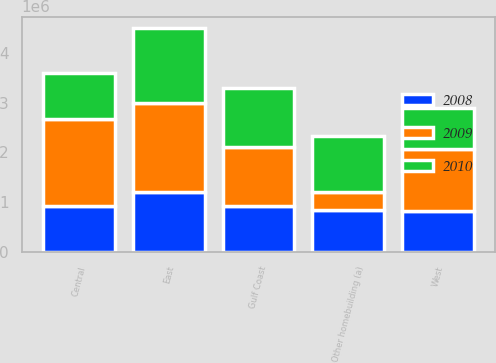<chart> <loc_0><loc_0><loc_500><loc_500><stacked_bar_chart><ecel><fcel>East<fcel>Gulf Coast<fcel>Central<fcel>West<fcel>Other homebuilding (a)<nl><fcel>2010<fcel>1.50679e+06<fcel>1.17842e+06<fcel>925285<fcel>809318<fcel>1.12717e+06<nl><fcel>2008<fcel>1.20178e+06<fcel>920960<fcel>930842<fcel>815713<fcel>839101<nl><fcel>2009<fcel>1.79438e+06<fcel>1.19483e+06<fcel>1.7335e+06<fcel>1.25758e+06<fcel>362285<nl></chart> 